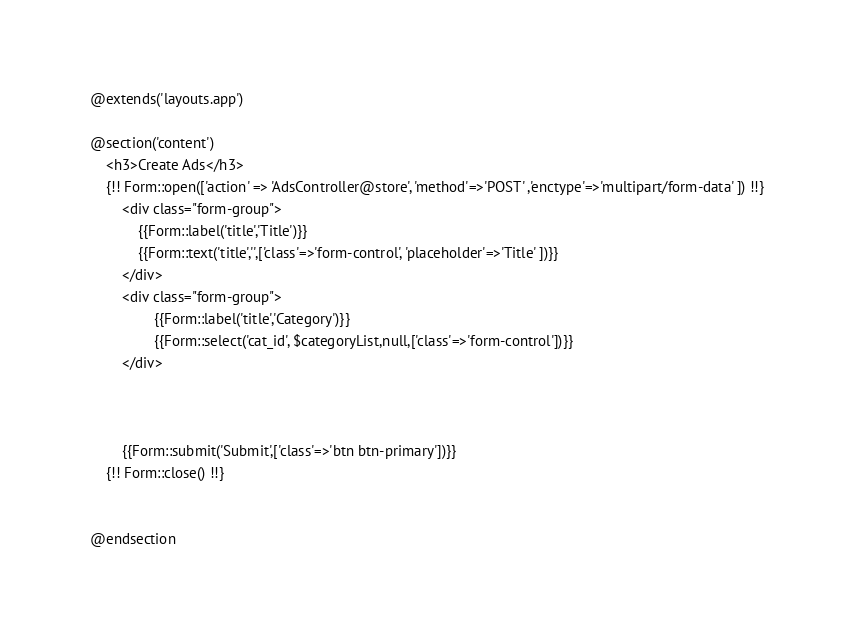Convert code to text. <code><loc_0><loc_0><loc_500><loc_500><_PHP_>@extends('layouts.app')

@section('content')
    <h3>Create Ads</h3>
    {!! Form::open(['action' => 'AdsController@store', 'method'=>'POST' ,'enctype'=>'multipart/form-data' ]) !!}
        <div class="form-group">
            {{Form::label('title','Title')}}
            {{Form::text('title','',['class'=>'form-control', 'placeholder'=>'Title' ])}}
        </div>
        <div class="form-group">
                {{Form::label('title','Category')}}
                {{Form::select('cat_id', $categoryList,null,['class'=>'form-control'])}}
        </div>

        
       
        {{Form::submit('Submit',['class'=>'btn btn-primary'])}}
    {!! Form::close() !!}   


@endsection</code> 